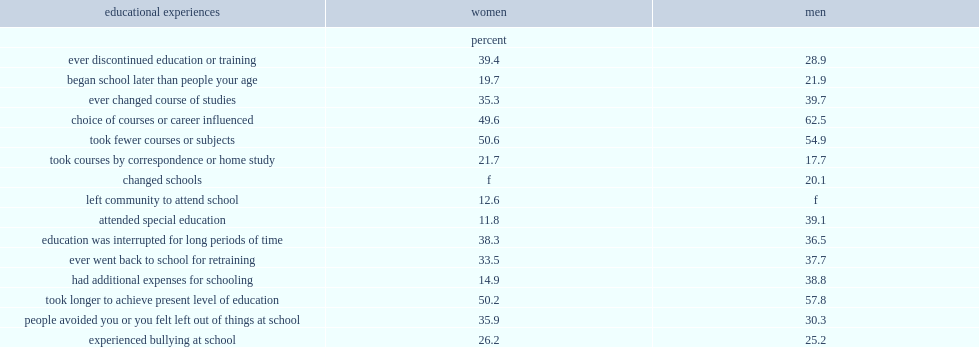What was the percentage of women with disabilities aged 25 to 34 who had attended school in the past five years reported that they took fewer courses or subjects? 50.6. What was the percentage of women with disabilities aged 25 to 34 who had attended school in the past five years reported that they took them longer to achieve their present level of education? 50.2. What was the percentage of women with disabilities aged 25 to 34 who had attended school in the past five years reported that their choice of courses or career was influenced because of their condition? 49.6. In 2012, what was the percentage of men with disabilities aged 25 to 34 who attended school in the past five years had reported that their choice of courses or career was influenced because of their condition? 62.5. What was the percentage of men reported that it took them longer to achieve their present level of education? 57.8. What was the percentage of men reported thatthey took fewer courses or subjects because of their condition? 54.9. 